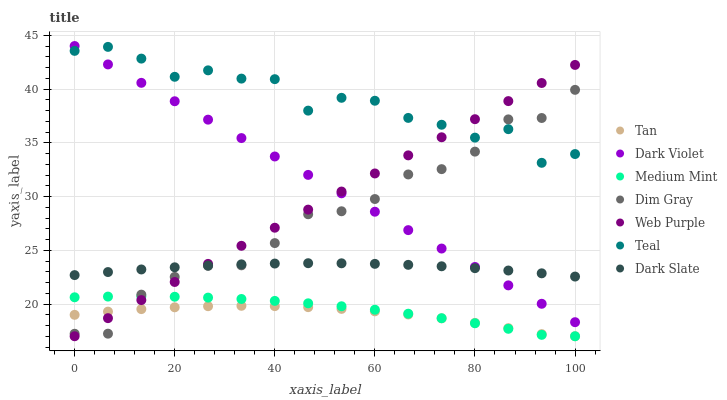Does Tan have the minimum area under the curve?
Answer yes or no. Yes. Does Teal have the maximum area under the curve?
Answer yes or no. Yes. Does Dim Gray have the minimum area under the curve?
Answer yes or no. No. Does Dim Gray have the maximum area under the curve?
Answer yes or no. No. Is Dark Violet the smoothest?
Answer yes or no. Yes. Is Teal the roughest?
Answer yes or no. Yes. Is Dim Gray the smoothest?
Answer yes or no. No. Is Dim Gray the roughest?
Answer yes or no. No. Does Medium Mint have the lowest value?
Answer yes or no. Yes. Does Dim Gray have the lowest value?
Answer yes or no. No. Does Dark Violet have the highest value?
Answer yes or no. Yes. Does Dim Gray have the highest value?
Answer yes or no. No. Is Medium Mint less than Teal?
Answer yes or no. Yes. Is Teal greater than Medium Mint?
Answer yes or no. Yes. Does Web Purple intersect Teal?
Answer yes or no. Yes. Is Web Purple less than Teal?
Answer yes or no. No. Is Web Purple greater than Teal?
Answer yes or no. No. Does Medium Mint intersect Teal?
Answer yes or no. No. 